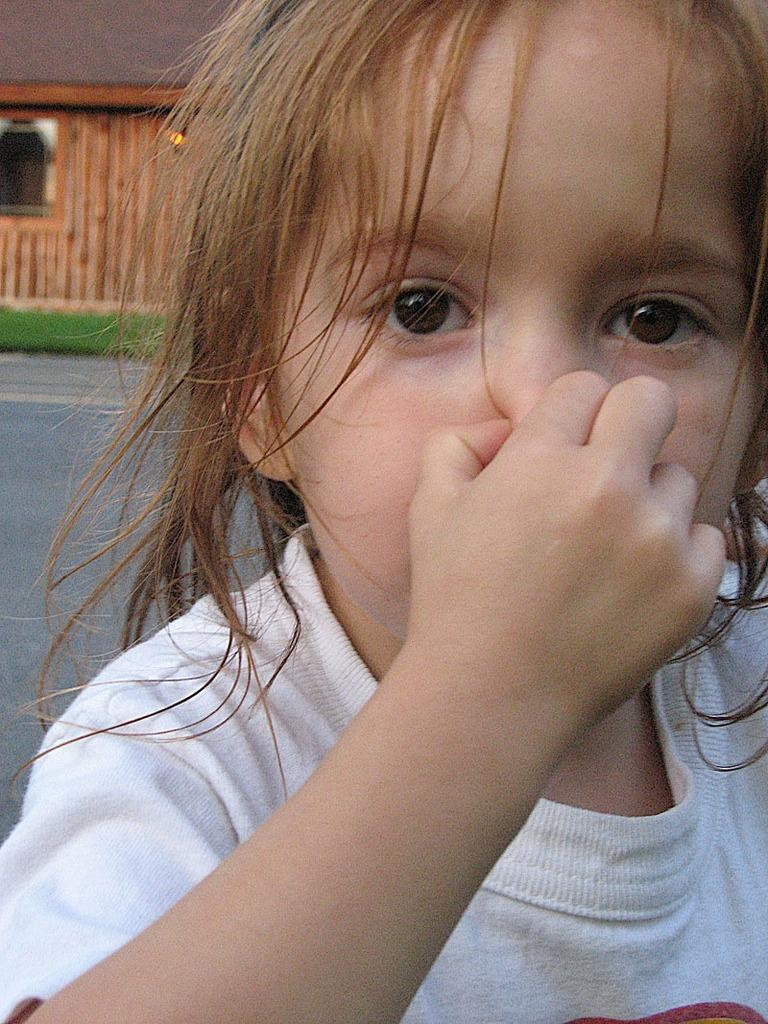What is the main subject of the picture? The main subject of the picture is a kid. What is the kid doing in the image? The kid is holding his nose. Can you describe the background of the image? The background of the image is blurred, but there are plants, a road, and a house visible. What type of pen can be seen in the kid's hand in the image? There is no pen visible in the kid's hand in the image. Is there a camera present in the image? There is no camera visible in the image. 